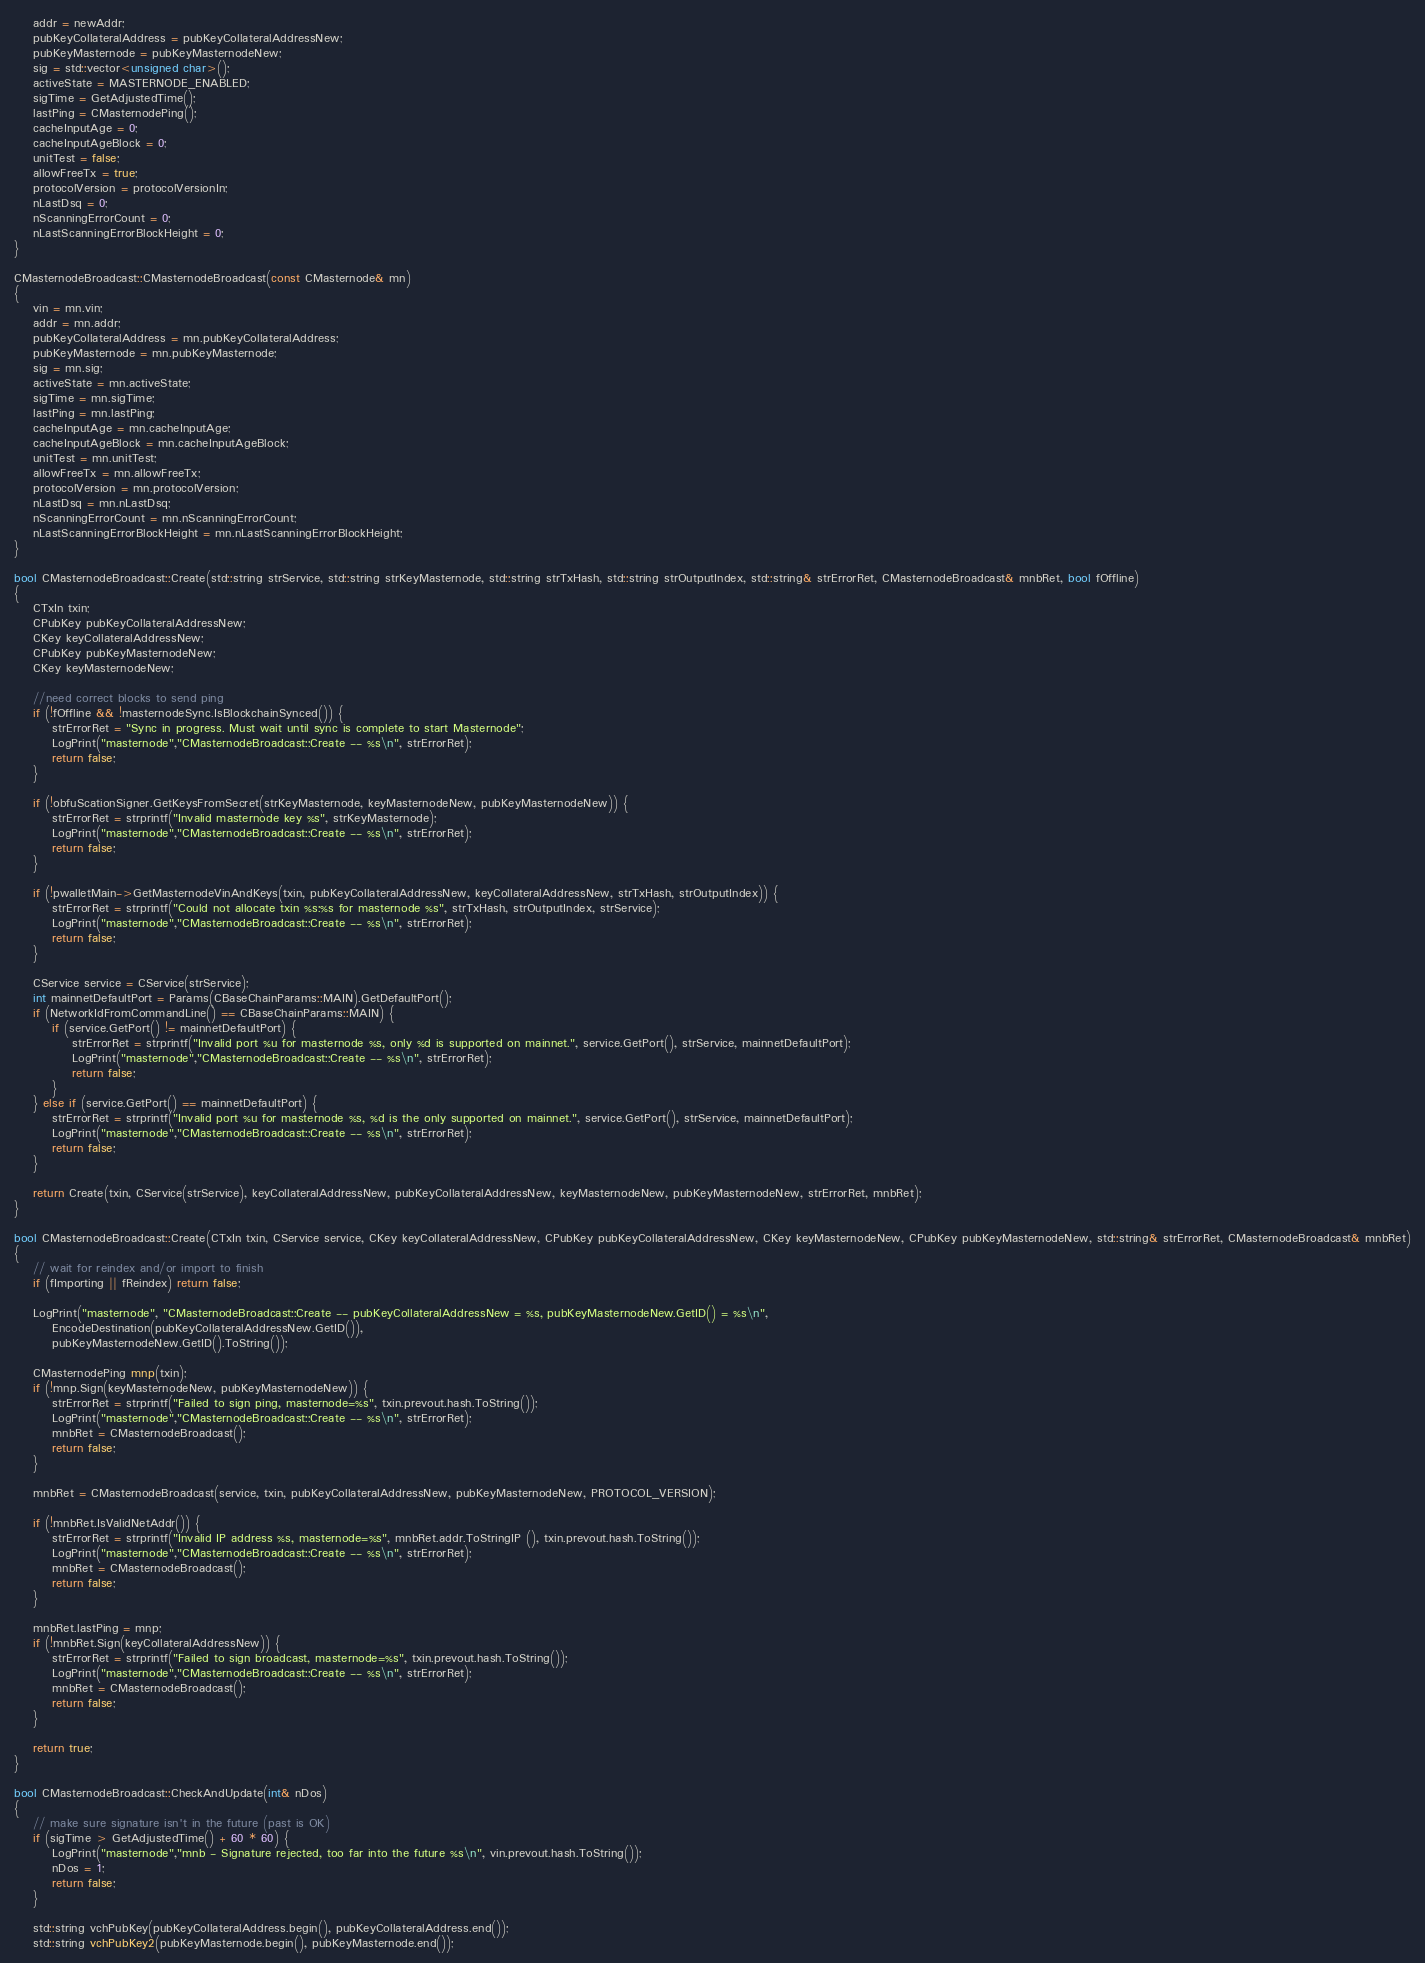<code> <loc_0><loc_0><loc_500><loc_500><_C++_>    addr = newAddr;
    pubKeyCollateralAddress = pubKeyCollateralAddressNew;
    pubKeyMasternode = pubKeyMasternodeNew;
    sig = std::vector<unsigned char>();
    activeState = MASTERNODE_ENABLED;
    sigTime = GetAdjustedTime();
    lastPing = CMasternodePing();
    cacheInputAge = 0;
    cacheInputAgeBlock = 0;
    unitTest = false;
    allowFreeTx = true;
    protocolVersion = protocolVersionIn;
    nLastDsq = 0;
    nScanningErrorCount = 0;
    nLastScanningErrorBlockHeight = 0;
}

CMasternodeBroadcast::CMasternodeBroadcast(const CMasternode& mn)
{
    vin = mn.vin;
    addr = mn.addr;
    pubKeyCollateralAddress = mn.pubKeyCollateralAddress;
    pubKeyMasternode = mn.pubKeyMasternode;
    sig = mn.sig;
    activeState = mn.activeState;
    sigTime = mn.sigTime;
    lastPing = mn.lastPing;
    cacheInputAge = mn.cacheInputAge;
    cacheInputAgeBlock = mn.cacheInputAgeBlock;
    unitTest = mn.unitTest;
    allowFreeTx = mn.allowFreeTx;
    protocolVersion = mn.protocolVersion;
    nLastDsq = mn.nLastDsq;
    nScanningErrorCount = mn.nScanningErrorCount;
    nLastScanningErrorBlockHeight = mn.nLastScanningErrorBlockHeight;
}

bool CMasternodeBroadcast::Create(std::string strService, std::string strKeyMasternode, std::string strTxHash, std::string strOutputIndex, std::string& strErrorRet, CMasternodeBroadcast& mnbRet, bool fOffline)
{
    CTxIn txin;
    CPubKey pubKeyCollateralAddressNew;
    CKey keyCollateralAddressNew;
    CPubKey pubKeyMasternodeNew;
    CKey keyMasternodeNew;

    //need correct blocks to send ping
    if (!fOffline && !masternodeSync.IsBlockchainSynced()) {
        strErrorRet = "Sync in progress. Must wait until sync is complete to start Masternode";
        LogPrint("masternode","CMasternodeBroadcast::Create -- %s\n", strErrorRet);
        return false;
    }

    if (!obfuScationSigner.GetKeysFromSecret(strKeyMasternode, keyMasternodeNew, pubKeyMasternodeNew)) {
        strErrorRet = strprintf("Invalid masternode key %s", strKeyMasternode);
        LogPrint("masternode","CMasternodeBroadcast::Create -- %s\n", strErrorRet);
        return false;
    }

    if (!pwalletMain->GetMasternodeVinAndKeys(txin, pubKeyCollateralAddressNew, keyCollateralAddressNew, strTxHash, strOutputIndex)) {
        strErrorRet = strprintf("Could not allocate txin %s:%s for masternode %s", strTxHash, strOutputIndex, strService);
        LogPrint("masternode","CMasternodeBroadcast::Create -- %s\n", strErrorRet);
        return false;
    }

    CService service = CService(strService);
    int mainnetDefaultPort = Params(CBaseChainParams::MAIN).GetDefaultPort();
    if (NetworkIdFromCommandLine() == CBaseChainParams::MAIN) {
        if (service.GetPort() != mainnetDefaultPort) {
            strErrorRet = strprintf("Invalid port %u for masternode %s, only %d is supported on mainnet.", service.GetPort(), strService, mainnetDefaultPort);
            LogPrint("masternode","CMasternodeBroadcast::Create -- %s\n", strErrorRet);
            return false;
        }
    } else if (service.GetPort() == mainnetDefaultPort) {
        strErrorRet = strprintf("Invalid port %u for masternode %s, %d is the only supported on mainnet.", service.GetPort(), strService, mainnetDefaultPort);
        LogPrint("masternode","CMasternodeBroadcast::Create -- %s\n", strErrorRet);
        return false;
    }

    return Create(txin, CService(strService), keyCollateralAddressNew, pubKeyCollateralAddressNew, keyMasternodeNew, pubKeyMasternodeNew, strErrorRet, mnbRet);
}

bool CMasternodeBroadcast::Create(CTxIn txin, CService service, CKey keyCollateralAddressNew, CPubKey pubKeyCollateralAddressNew, CKey keyMasternodeNew, CPubKey pubKeyMasternodeNew, std::string& strErrorRet, CMasternodeBroadcast& mnbRet)
{
    // wait for reindex and/or import to finish
    if (fImporting || fReindex) return false;

    LogPrint("masternode", "CMasternodeBroadcast::Create -- pubKeyCollateralAddressNew = %s, pubKeyMasternodeNew.GetID() = %s\n",
        EncodeDestination(pubKeyCollateralAddressNew.GetID()),
        pubKeyMasternodeNew.GetID().ToString());

    CMasternodePing mnp(txin);
    if (!mnp.Sign(keyMasternodeNew, pubKeyMasternodeNew)) {
        strErrorRet = strprintf("Failed to sign ping, masternode=%s", txin.prevout.hash.ToString());
        LogPrint("masternode","CMasternodeBroadcast::Create -- %s\n", strErrorRet);
        mnbRet = CMasternodeBroadcast();
        return false;
    }

    mnbRet = CMasternodeBroadcast(service, txin, pubKeyCollateralAddressNew, pubKeyMasternodeNew, PROTOCOL_VERSION);

    if (!mnbRet.IsValidNetAddr()) {
        strErrorRet = strprintf("Invalid IP address %s, masternode=%s", mnbRet.addr.ToStringIP (), txin.prevout.hash.ToString());
        LogPrint("masternode","CMasternodeBroadcast::Create -- %s\n", strErrorRet);
        mnbRet = CMasternodeBroadcast();
        return false;
    }

    mnbRet.lastPing = mnp;
    if (!mnbRet.Sign(keyCollateralAddressNew)) {
        strErrorRet = strprintf("Failed to sign broadcast, masternode=%s", txin.prevout.hash.ToString());
        LogPrint("masternode","CMasternodeBroadcast::Create -- %s\n", strErrorRet);
        mnbRet = CMasternodeBroadcast();
        return false;
    }

    return true;
}

bool CMasternodeBroadcast::CheckAndUpdate(int& nDos)
{
    // make sure signature isn't in the future (past is OK)
    if (sigTime > GetAdjustedTime() + 60 * 60) {
        LogPrint("masternode","mnb - Signature rejected, too far into the future %s\n", vin.prevout.hash.ToString());
        nDos = 1;
        return false;
    }

    std::string vchPubKey(pubKeyCollateralAddress.begin(), pubKeyCollateralAddress.end());
    std::string vchPubKey2(pubKeyMasternode.begin(), pubKeyMasternode.end());</code> 